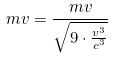<formula> <loc_0><loc_0><loc_500><loc_500>m v = \frac { m v } { \sqrt { 9 \cdot \frac { v ^ { 3 } } { c ^ { 3 } } } }</formula> 